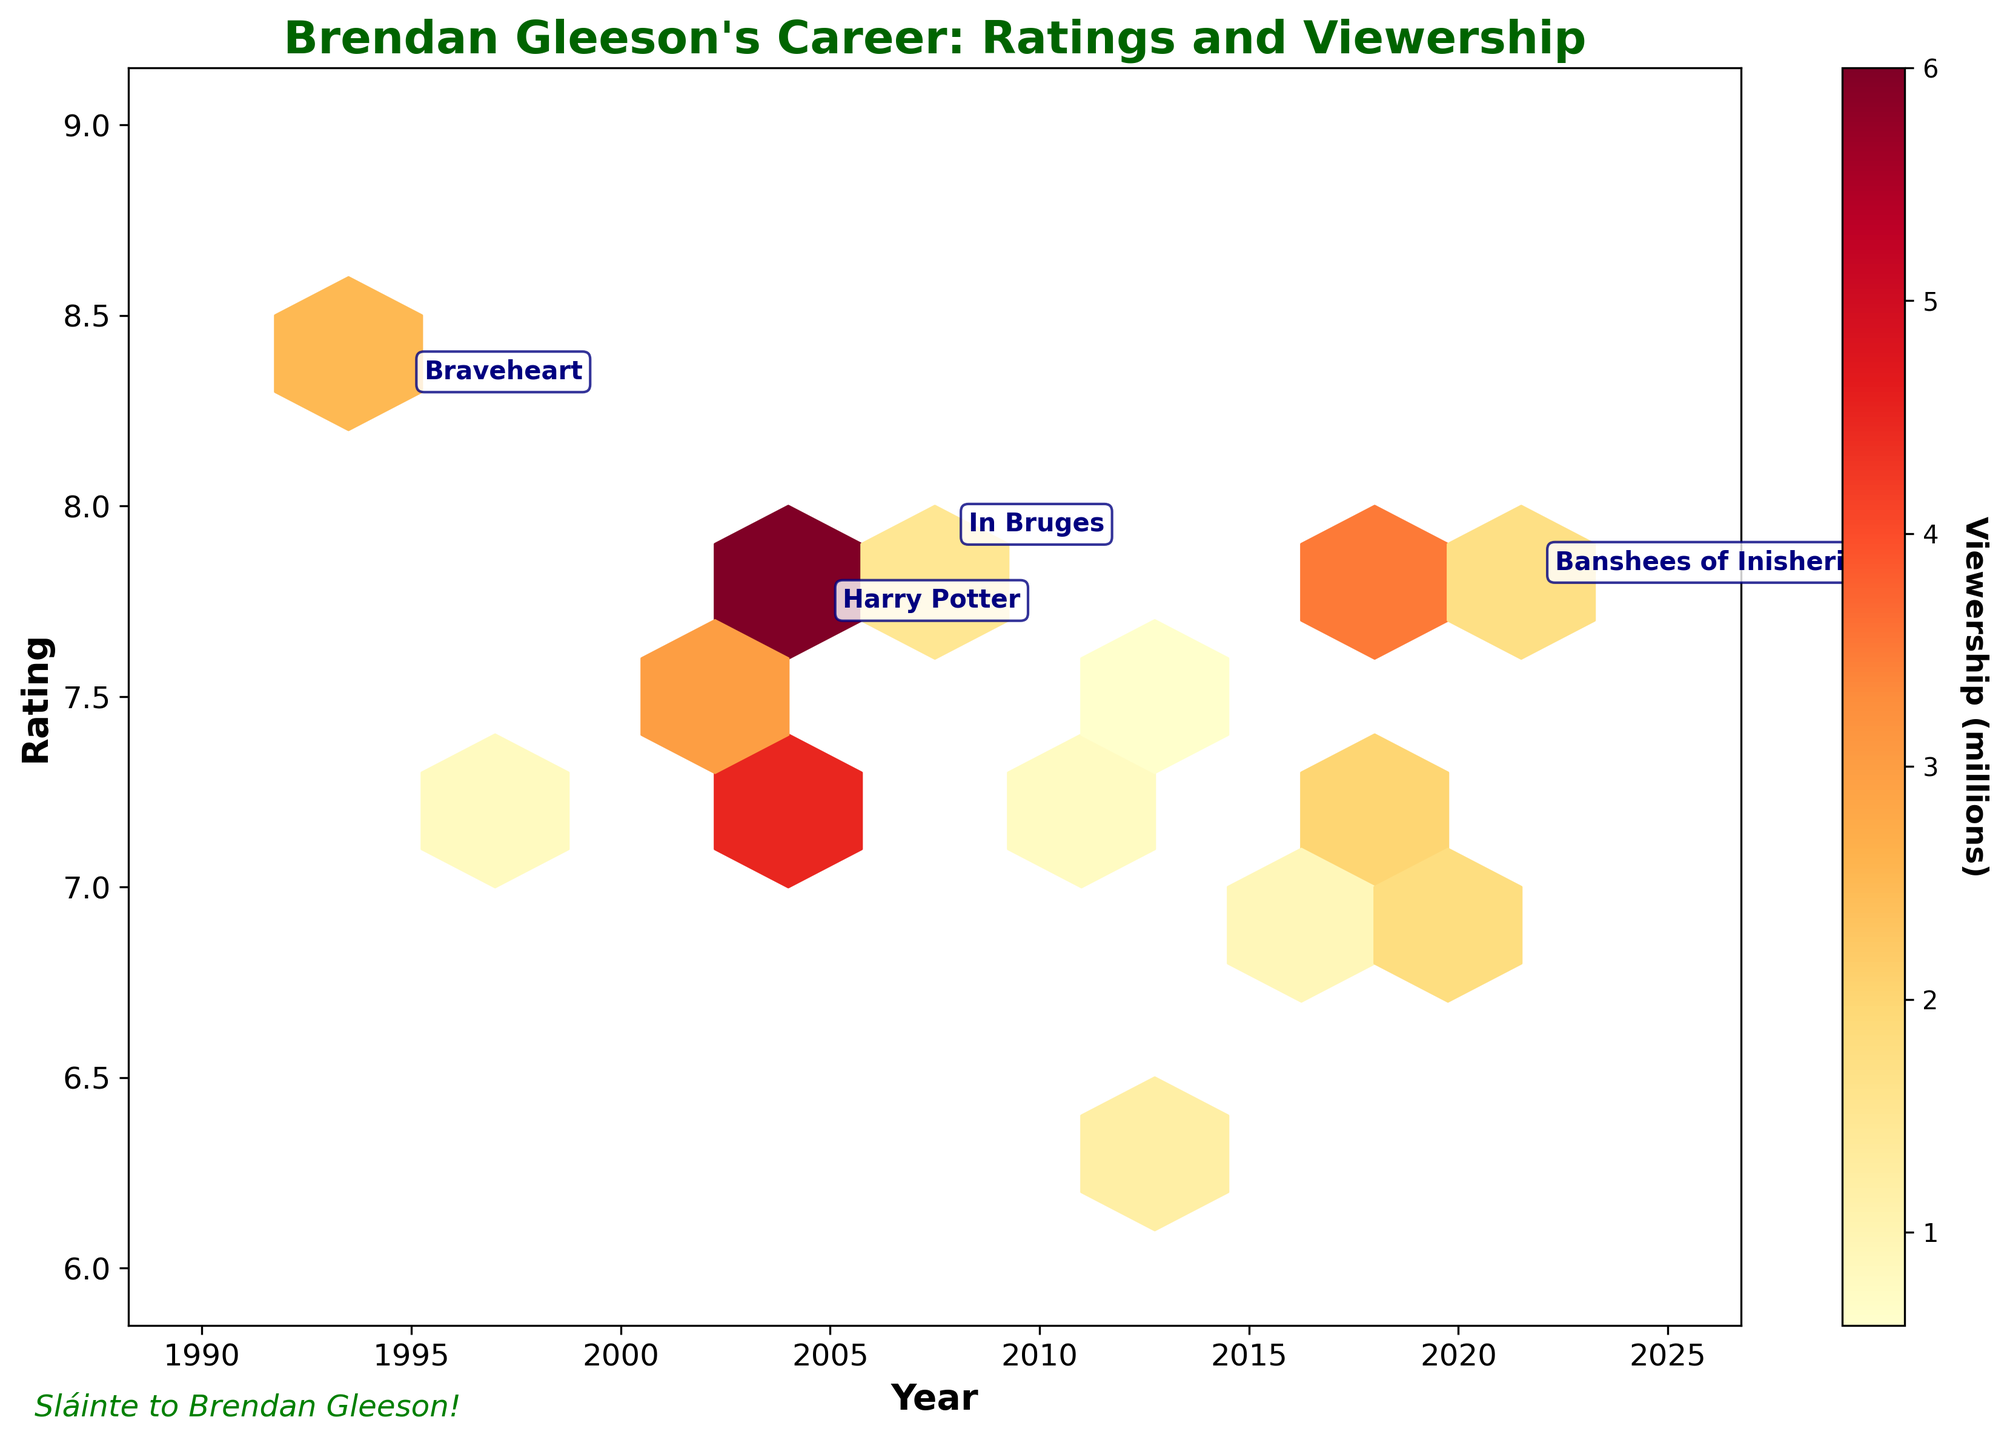What is the title of the plot? The title can be found at the top of the plot, displaying the main theme or purpose of the figure. Here, it reads "Brendan Gleeson's Career: Ratings and Viewership."
Answer: Brendan Gleeson's Career: Ratings and Viewership What is the color of the colorbar on the right side of the plot? The colorbar is located on the right side of the plot and shows the range of colors used, graduating from one color to another to represent different values. Here, it transitions from yellow to red.
Answer: Yellow to red How many points are highlighted as notable works in the scatter plot? The notable works are specifically annotated with text next to certain hexagons within the plot. By counting these annotations, we see there are 4: Braveheart (1995), Harry Potter (2005), In Bruges (2008), and Banshees of Inisherin (2022).
Answer: 4 What year had the highest viewership for Brendan Gleeson's movies and TV shows? The hexes’ color intensity indicates viewership, with darker colors showing higher viewership. According to the plot, the year 2005, corresponding to "Harry Potter and the Goblet of Fire," appears to have the darkest hex.
Answer: 2005 What range of movie ratings is covered in the plot? The y-axis represents the movie ratings, ranging from the lowest to the highest value shown. The plot's y-axis spans from 6 to 9, indicating this is the range of ratings covered.
Answer: 6 to 9 Which has a higher rating: "In Bruges" or "The Banshees of Inisherin"? To compare the ratings of these two movies, we look at their respective annotations and positions on the y-axis. "In Bruges" has a rating of 7.9, and "The Banshees of Inisherin" has a rating of 7.8, showing "In Bruges" is slightly higher.
Answer: In Bruges Which movie or TV show listed in the annotations has the lowest rating? The annotated works have ratings displayed next to them. By checking each, "Harry Potter and the Goblet of Fire" has a rating of 7.7, which is the lowest among the notable works highlighted.
Answer: Harry Potter What viewership category corresponds to the most frequent hexes on the plot? The densest hexes represent more frequently occurring viewership amounts. Examining the colorbar and intensity, the lighter yellow areas are more frequent, indicating viewership between 0-1 million viewers is common.
Answer: 0-1 million viewers What is the general trend between viewership and rating over the years? Observing the overall distribution and density, there doesn't appear to be a stark trend between viewership and rating. However, individual high-rating works (like "Harry Potter") do show high viewership, implying selected higher-rated titles attract more viewership.
Answer: No strong overall trend 